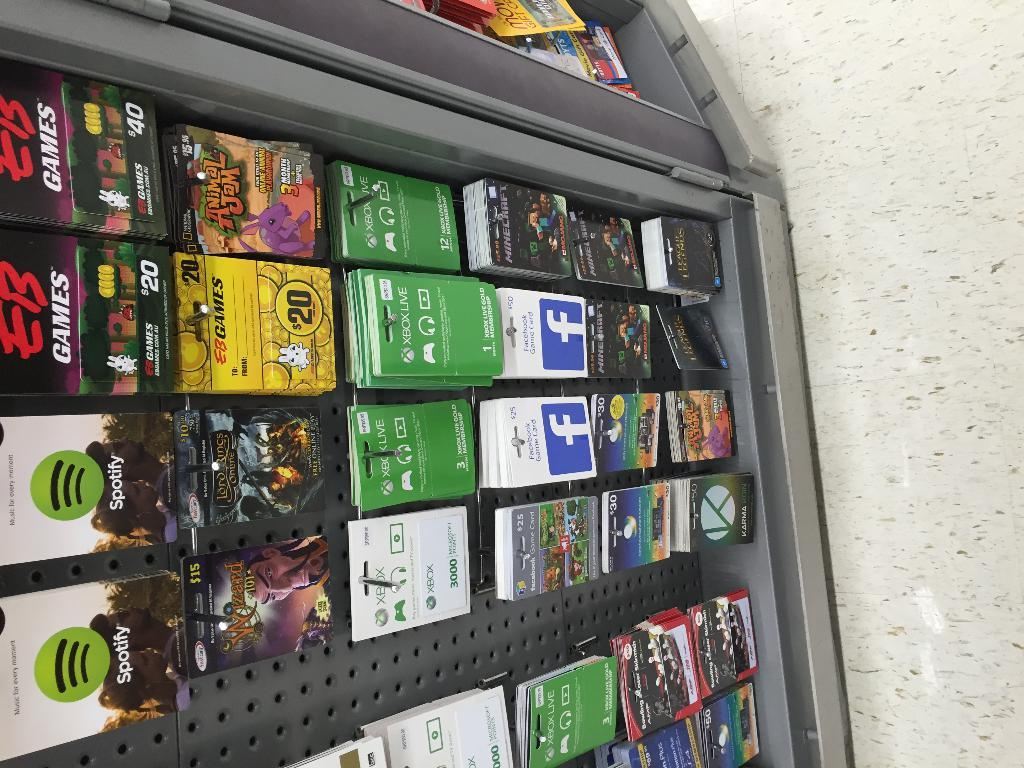<image>
Relay a brief, clear account of the picture shown. A rack of gift cards including ones for XBOX, Facebook, and EB Games. 